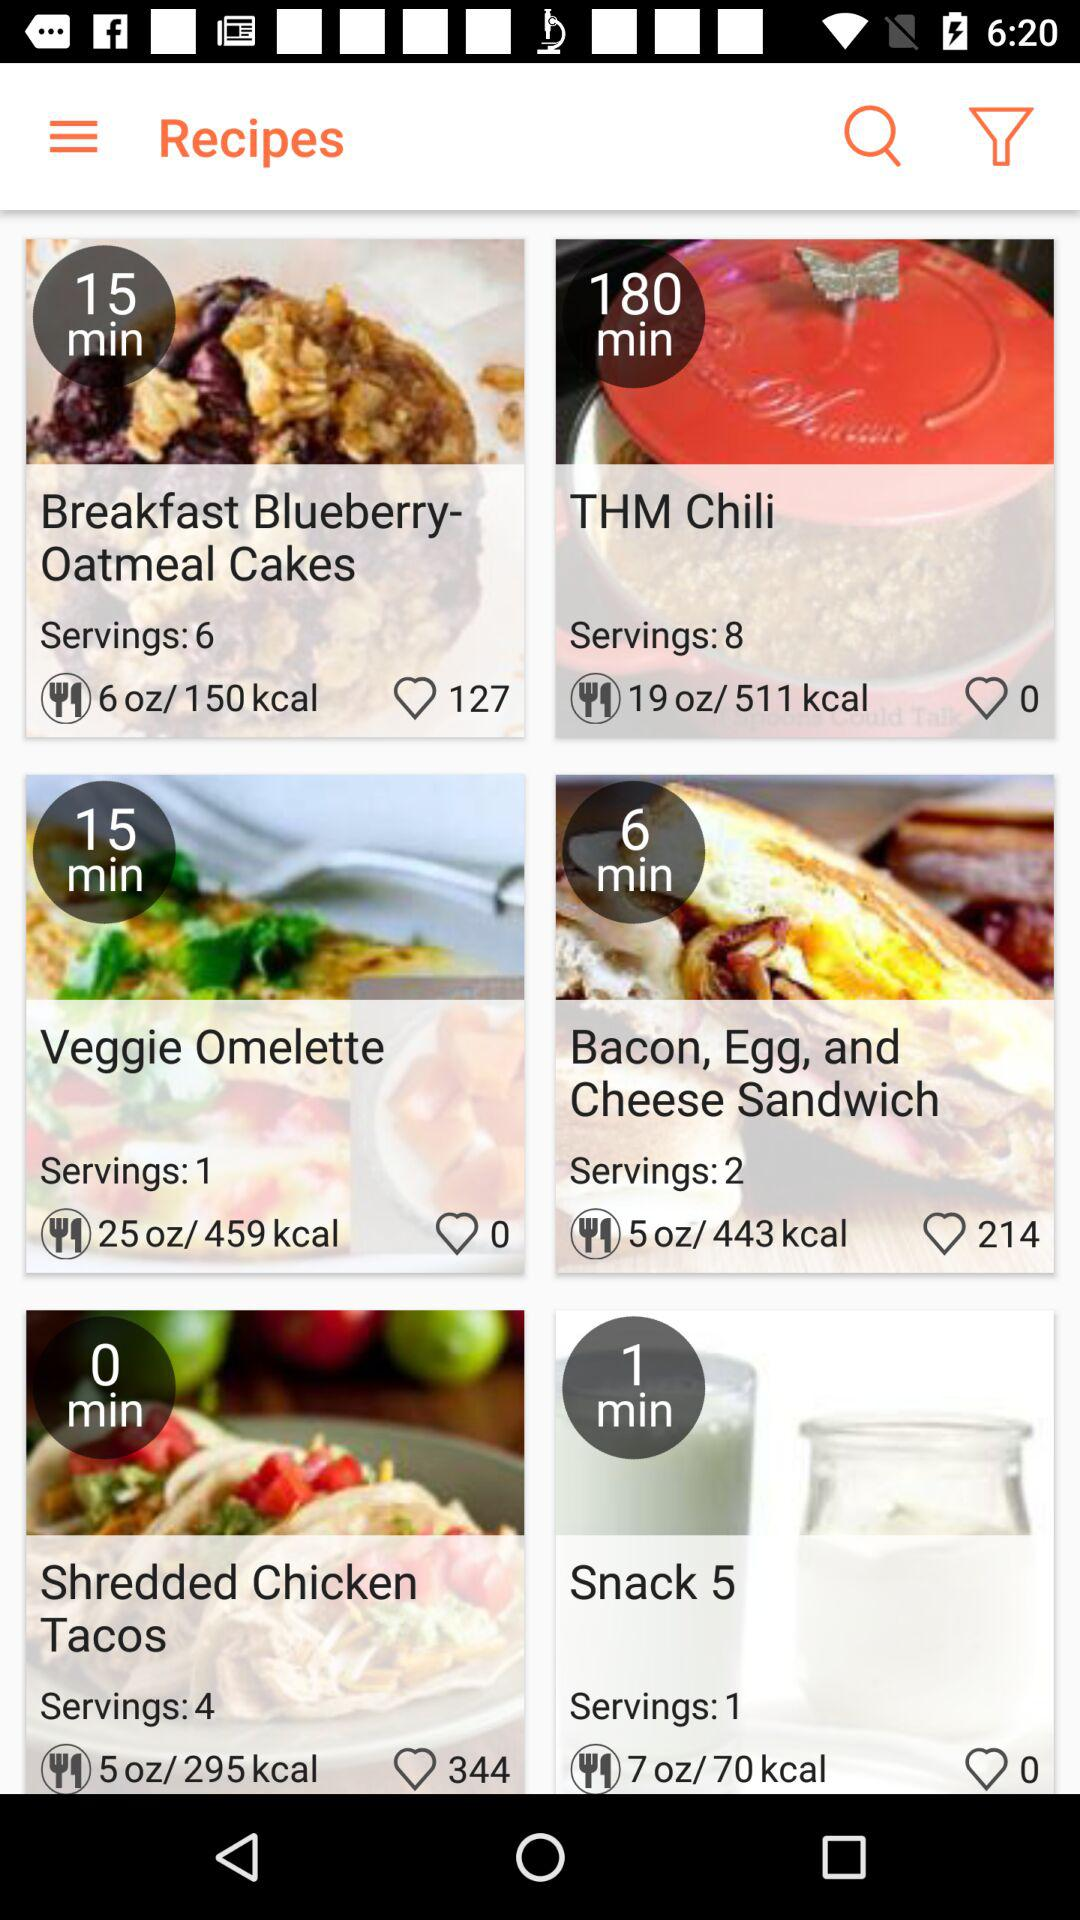How many likes are there on "Veggie Omelette"? There are 0 likes on "Veggie Omelette". 